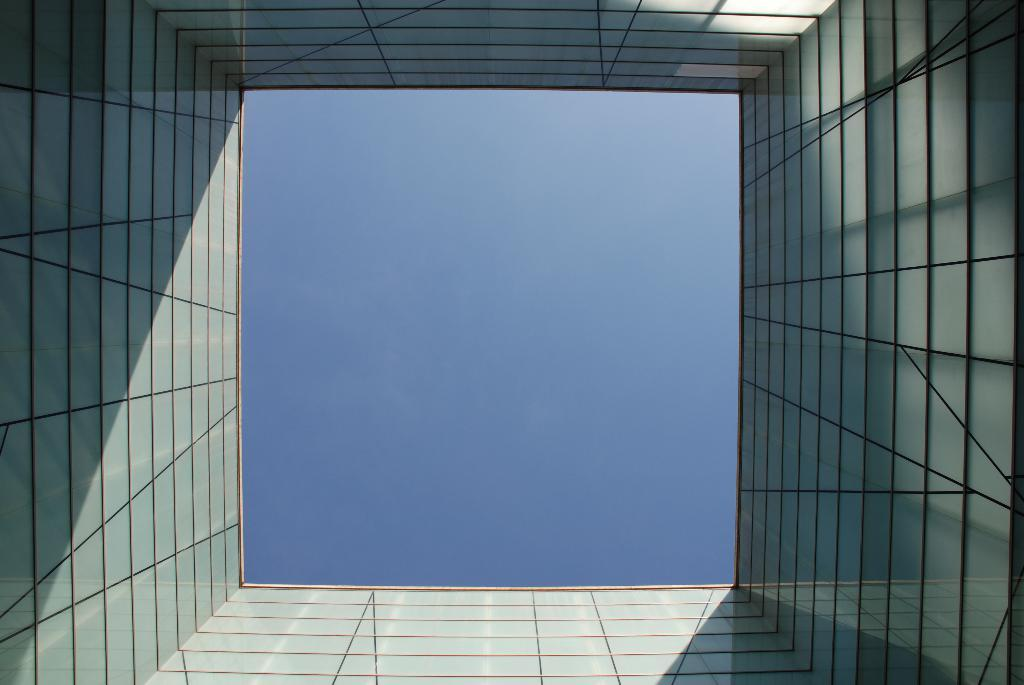What type of structure is visible in the image? There are walls of a building with glasses in the image. What can be seen in the background of the image? The sky is visible in the center of the image. How many pencils can be seen on the walls of the building in the image? There are no pencils visible on the walls of the building in the image. What is the mother doing in the image? There is no mother present in the image. 